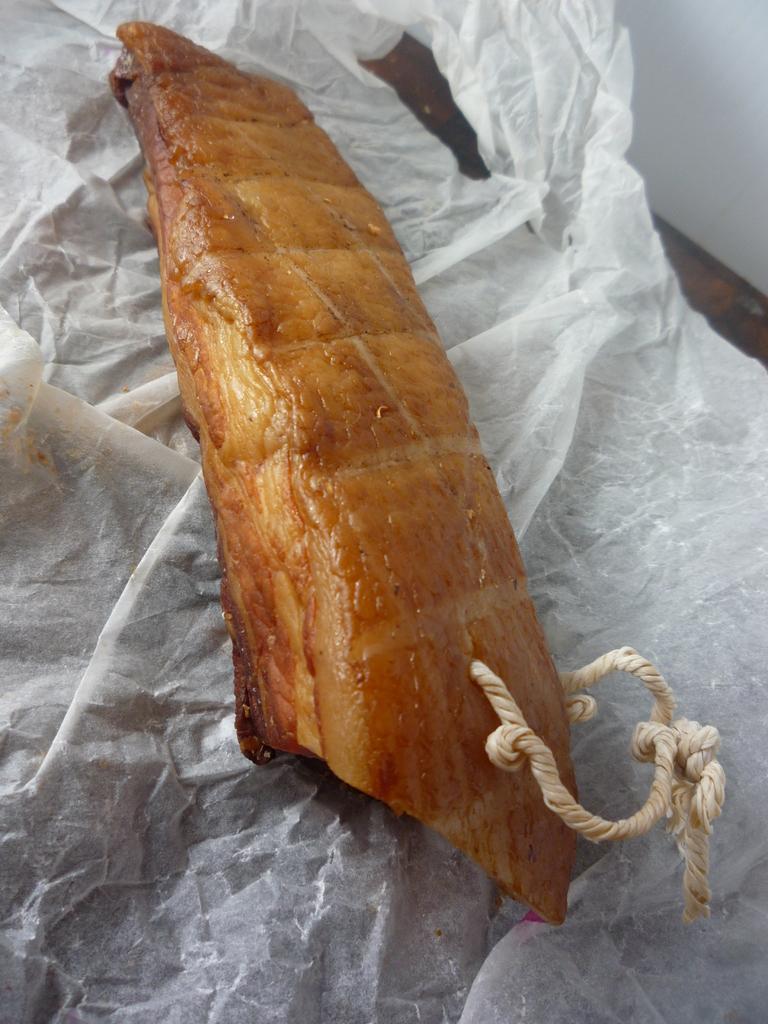In one or two sentences, can you explain what this image depicts? In this image I can see a food item on the tissue. In the background, I can see the table. 